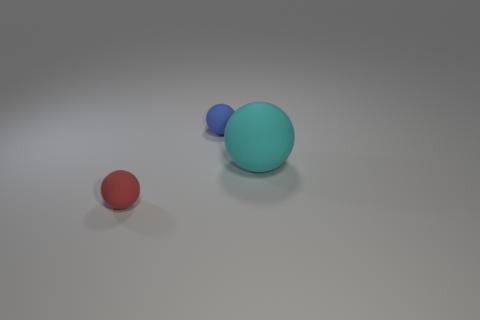Add 3 small spheres. How many objects exist? 6 Subtract all green shiny cubes. Subtract all small red balls. How many objects are left? 2 Add 1 small red rubber things. How many small red rubber things are left? 2 Add 1 tiny purple matte cylinders. How many tiny purple matte cylinders exist? 1 Subtract 0 red cylinders. How many objects are left? 3 